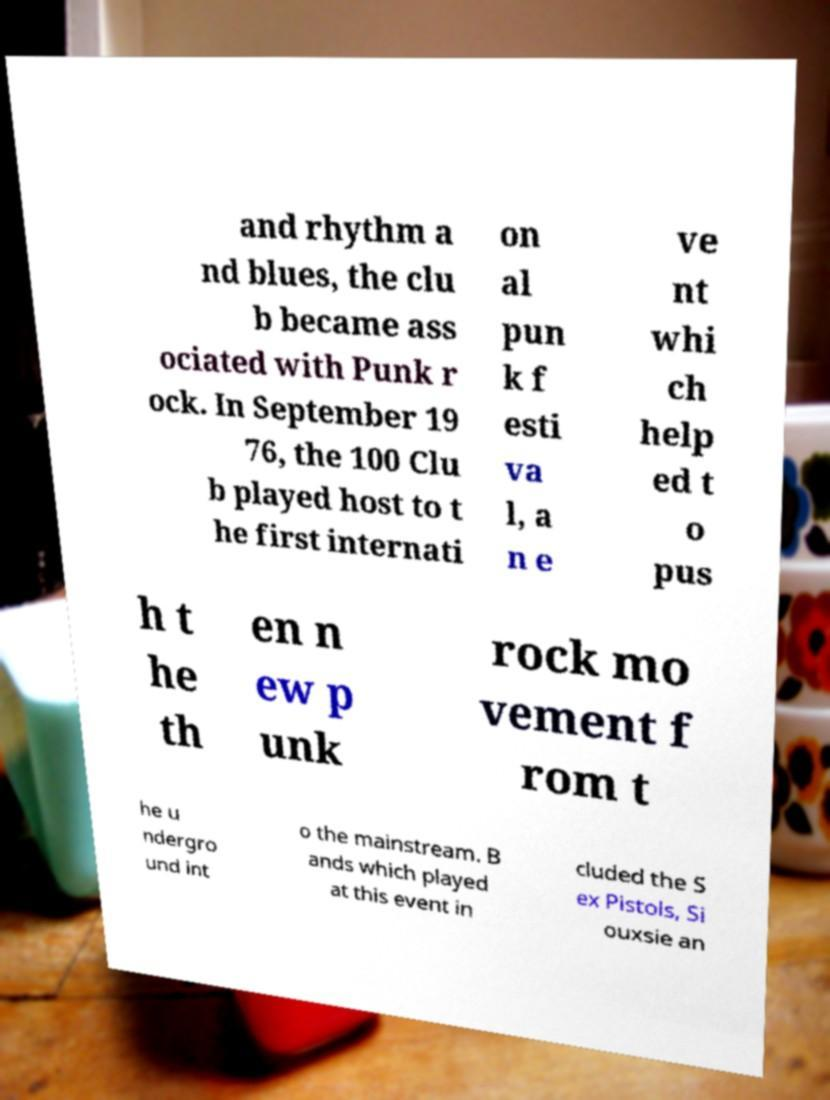Could you assist in decoding the text presented in this image and type it out clearly? and rhythm a nd blues, the clu b became ass ociated with Punk r ock. In September 19 76, the 100 Clu b played host to t he first internati on al pun k f esti va l, a n e ve nt whi ch help ed t o pus h t he th en n ew p unk rock mo vement f rom t he u ndergro und int o the mainstream. B ands which played at this event in cluded the S ex Pistols, Si ouxsie an 